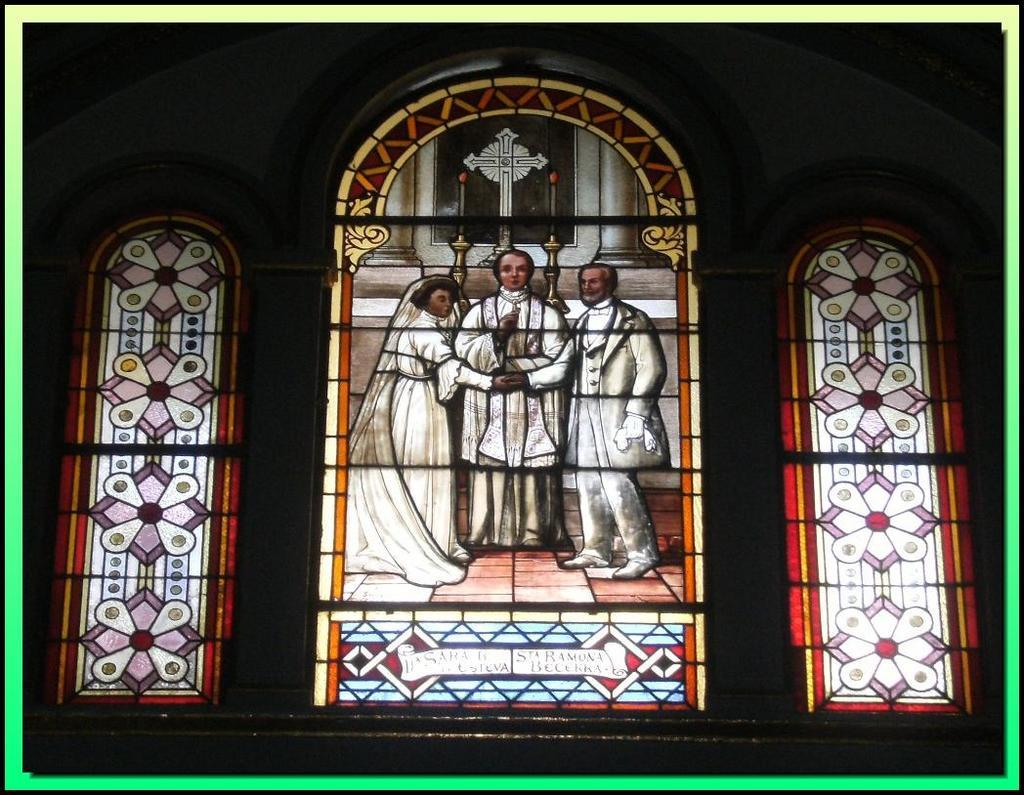What type of windows are depicted in the center of the image? There are stained glass windows in the center of the image. What type of waste can be seen being disposed of by the owner in the image? There is no waste or owner present in the image; it only features stained glass windows. 